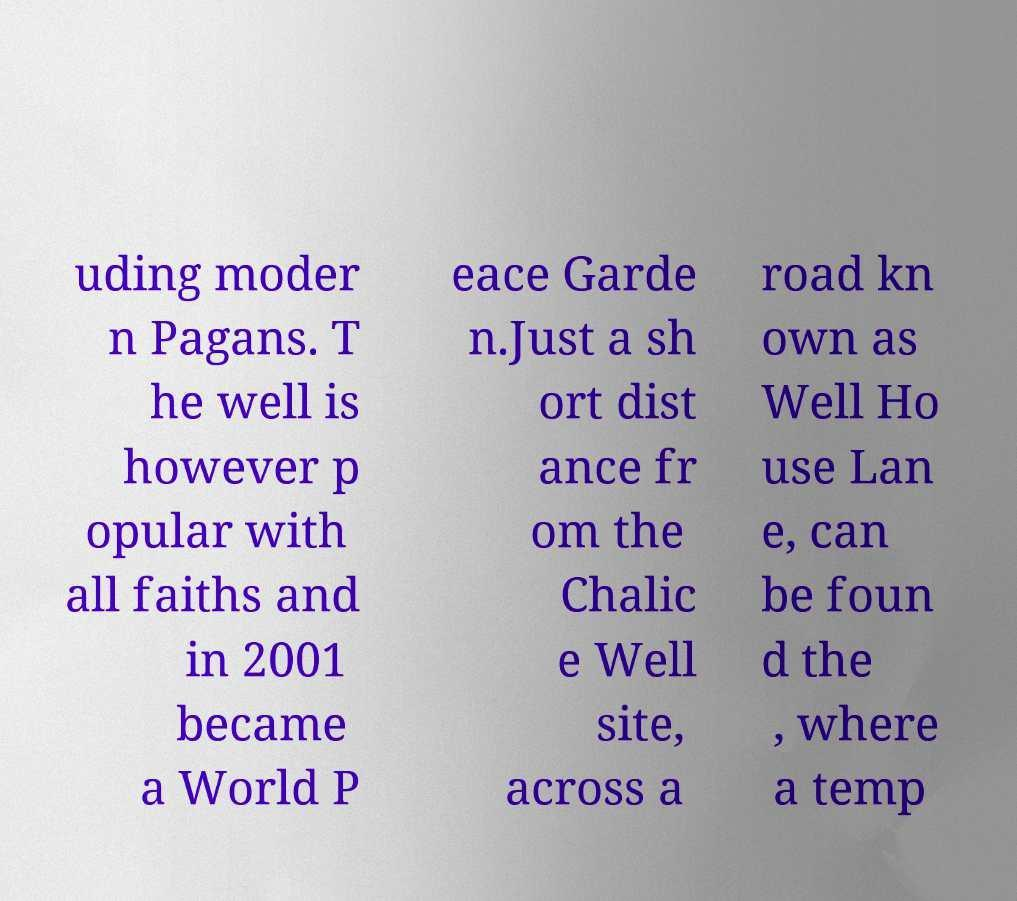Can you accurately transcribe the text from the provided image for me? uding moder n Pagans. T he well is however p opular with all faiths and in 2001 became a World P eace Garde n.Just a sh ort dist ance fr om the Chalic e Well site, across a road kn own as Well Ho use Lan e, can be foun d the , where a temp 